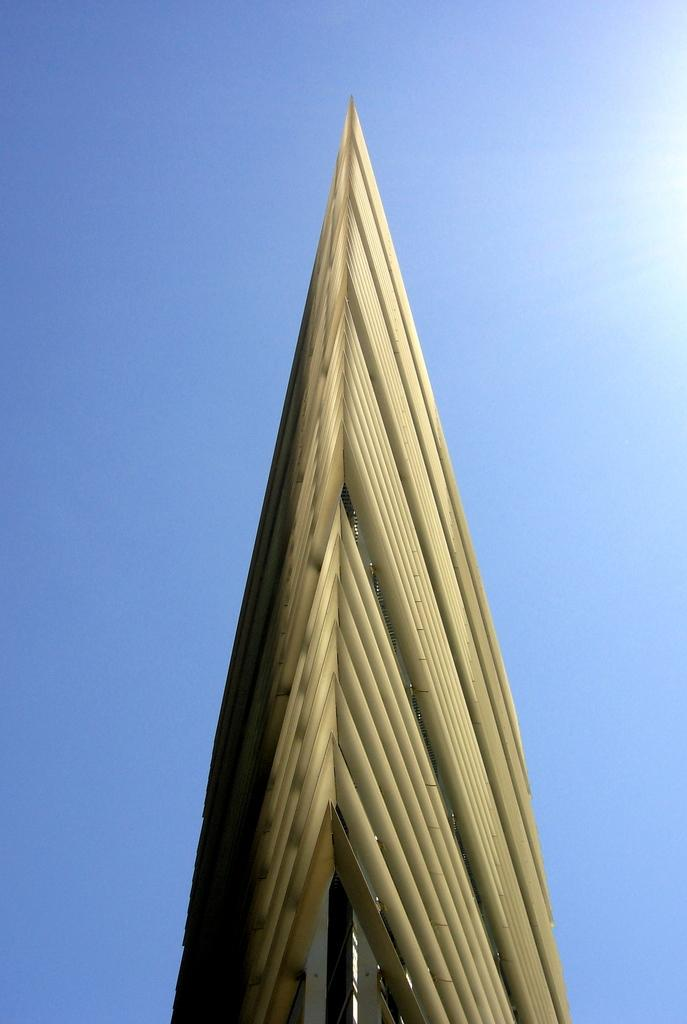What type of structure is visible in the image? There is an architecture in the image. What is the color of the sky in the image? The sky is blue in color. How many apples are being held by the children in the image? There are no children or apples present in the image. What type of rings are visible on the architecture in the image? There is no mention of rings in the provided facts, and therefore we cannot determine if any rings are visible on the architecture. 